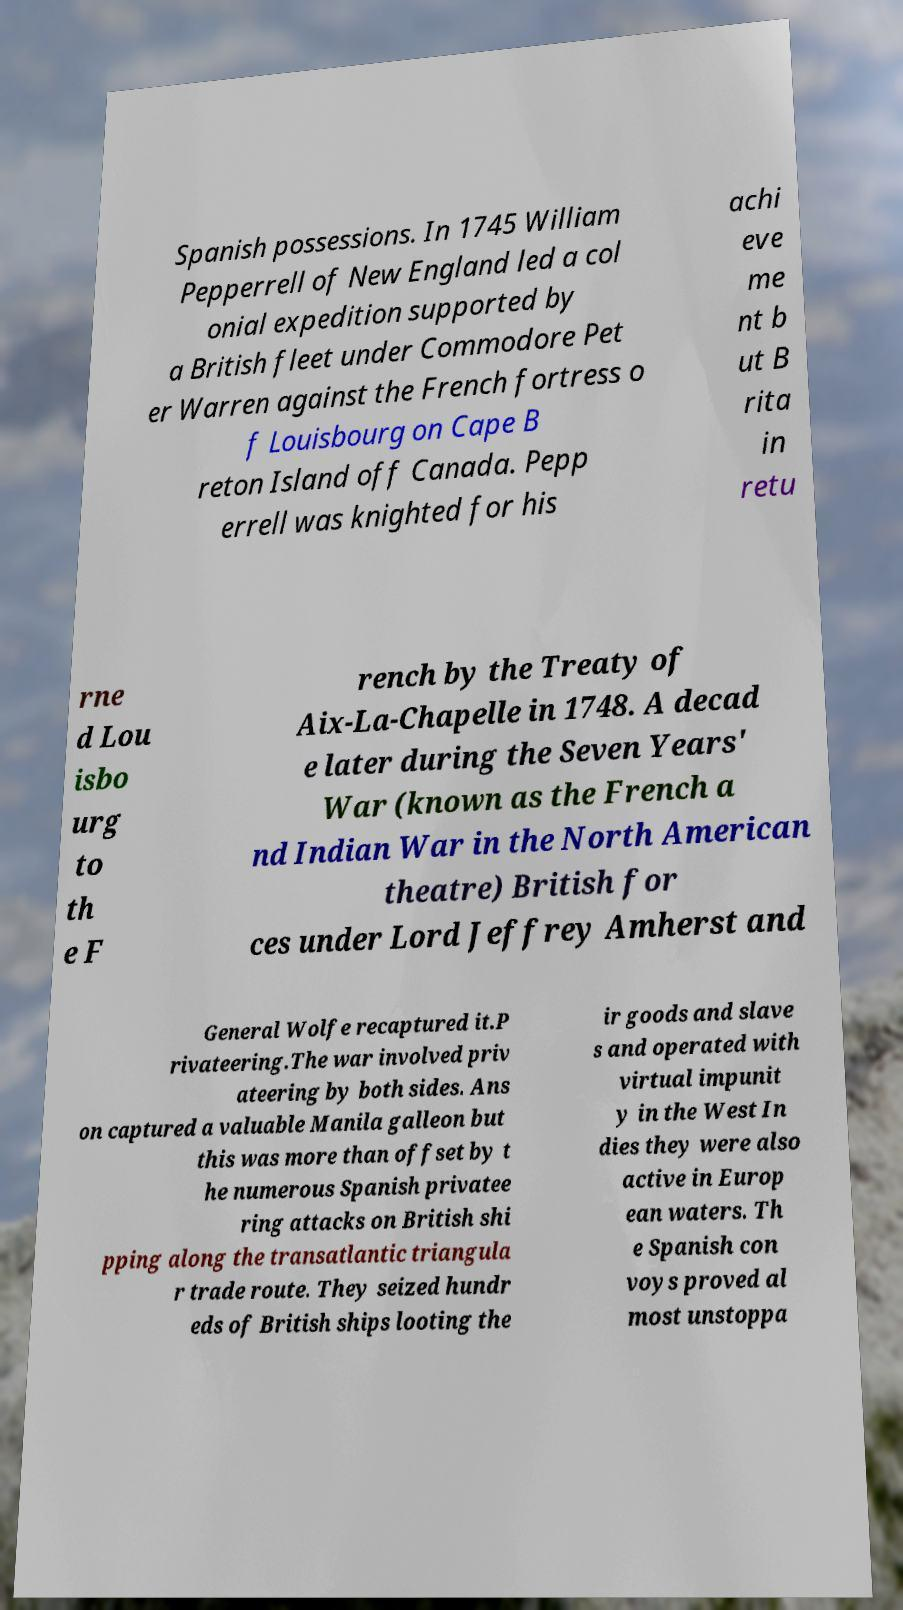I need the written content from this picture converted into text. Can you do that? Spanish possessions. In 1745 William Pepperrell of New England led a col onial expedition supported by a British fleet under Commodore Pet er Warren against the French fortress o f Louisbourg on Cape B reton Island off Canada. Pepp errell was knighted for his achi eve me nt b ut B rita in retu rne d Lou isbo urg to th e F rench by the Treaty of Aix-La-Chapelle in 1748. A decad e later during the Seven Years' War (known as the French a nd Indian War in the North American theatre) British for ces under Lord Jeffrey Amherst and General Wolfe recaptured it.P rivateering.The war involved priv ateering by both sides. Ans on captured a valuable Manila galleon but this was more than offset by t he numerous Spanish privatee ring attacks on British shi pping along the transatlantic triangula r trade route. They seized hundr eds of British ships looting the ir goods and slave s and operated with virtual impunit y in the West In dies they were also active in Europ ean waters. Th e Spanish con voys proved al most unstoppa 